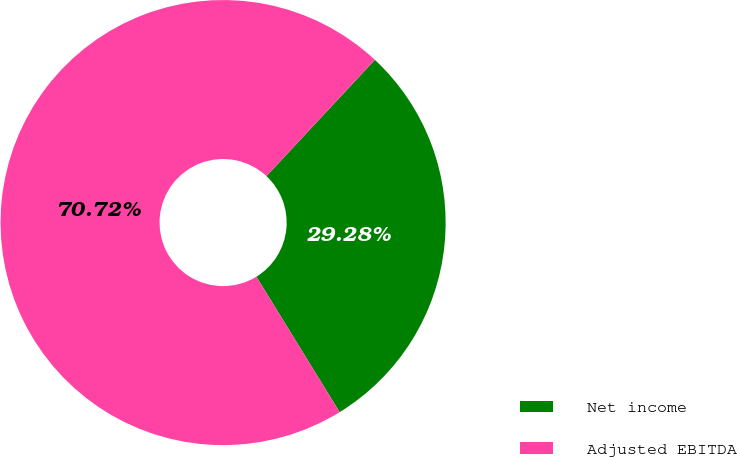Convert chart to OTSL. <chart><loc_0><loc_0><loc_500><loc_500><pie_chart><fcel>Net income<fcel>Adjusted EBITDA<nl><fcel>29.28%<fcel>70.72%<nl></chart> 